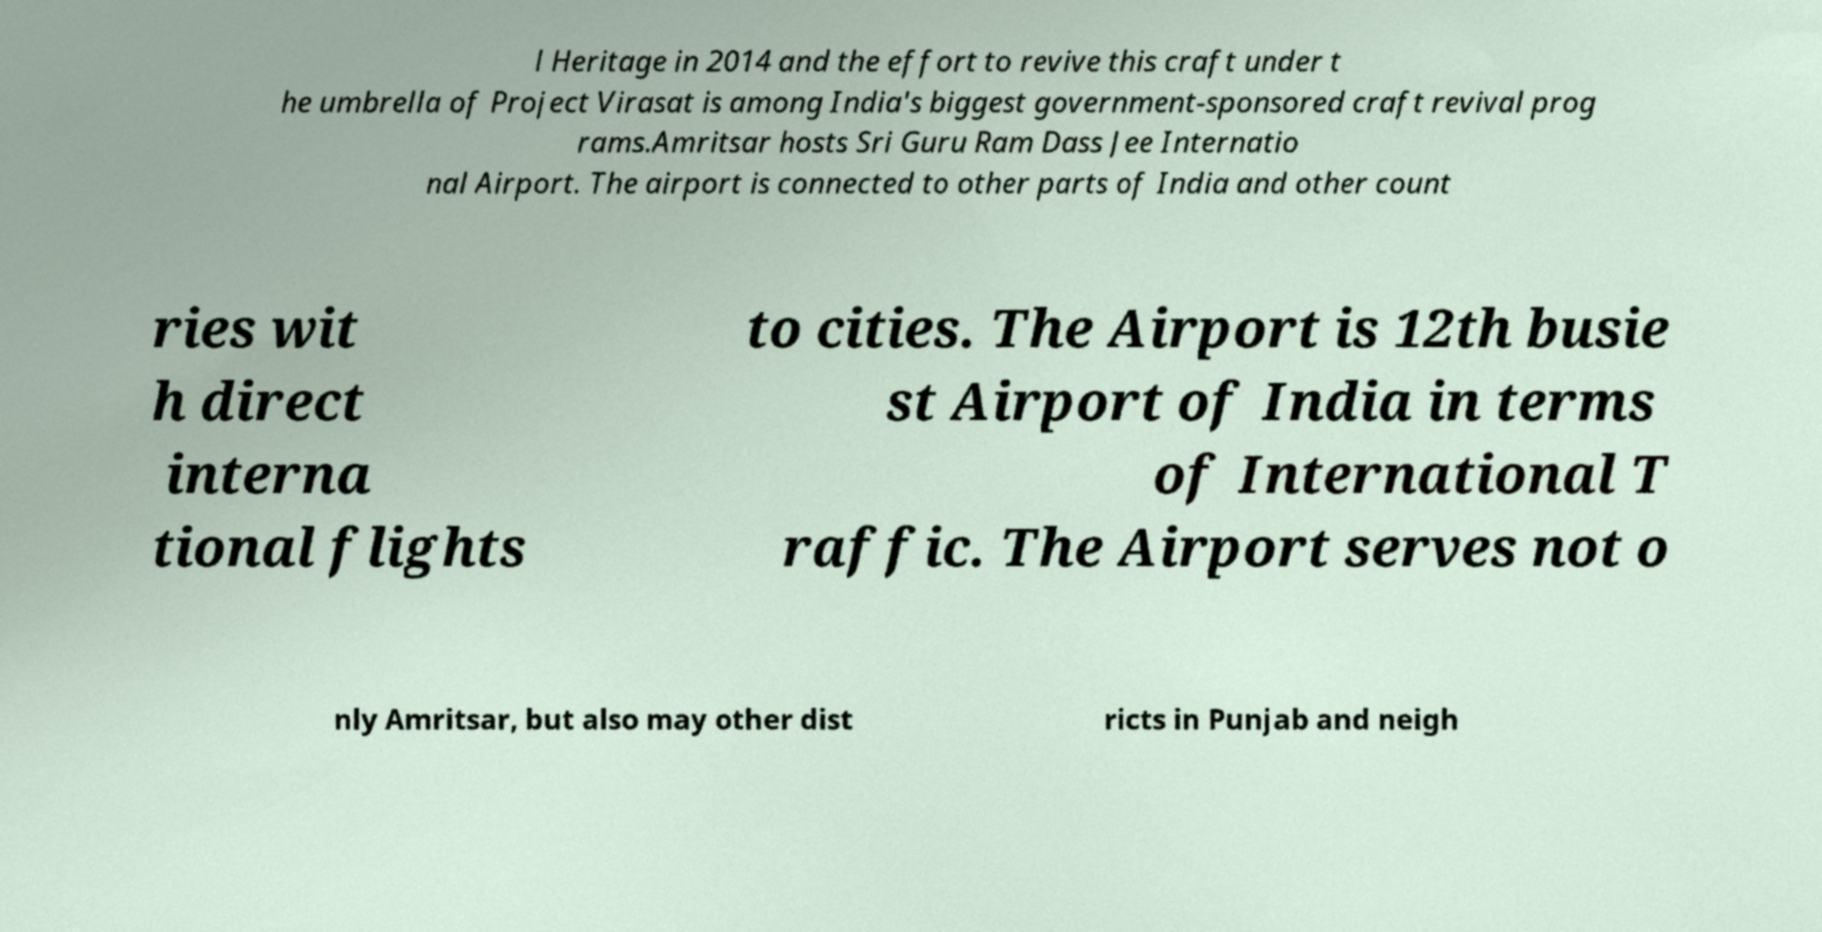There's text embedded in this image that I need extracted. Can you transcribe it verbatim? l Heritage in 2014 and the effort to revive this craft under t he umbrella of Project Virasat is among India's biggest government-sponsored craft revival prog rams.Amritsar hosts Sri Guru Ram Dass Jee Internatio nal Airport. The airport is connected to other parts of India and other count ries wit h direct interna tional flights to cities. The Airport is 12th busie st Airport of India in terms of International T raffic. The Airport serves not o nly Amritsar, but also may other dist ricts in Punjab and neigh 